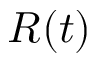<formula> <loc_0><loc_0><loc_500><loc_500>R ( t )</formula> 